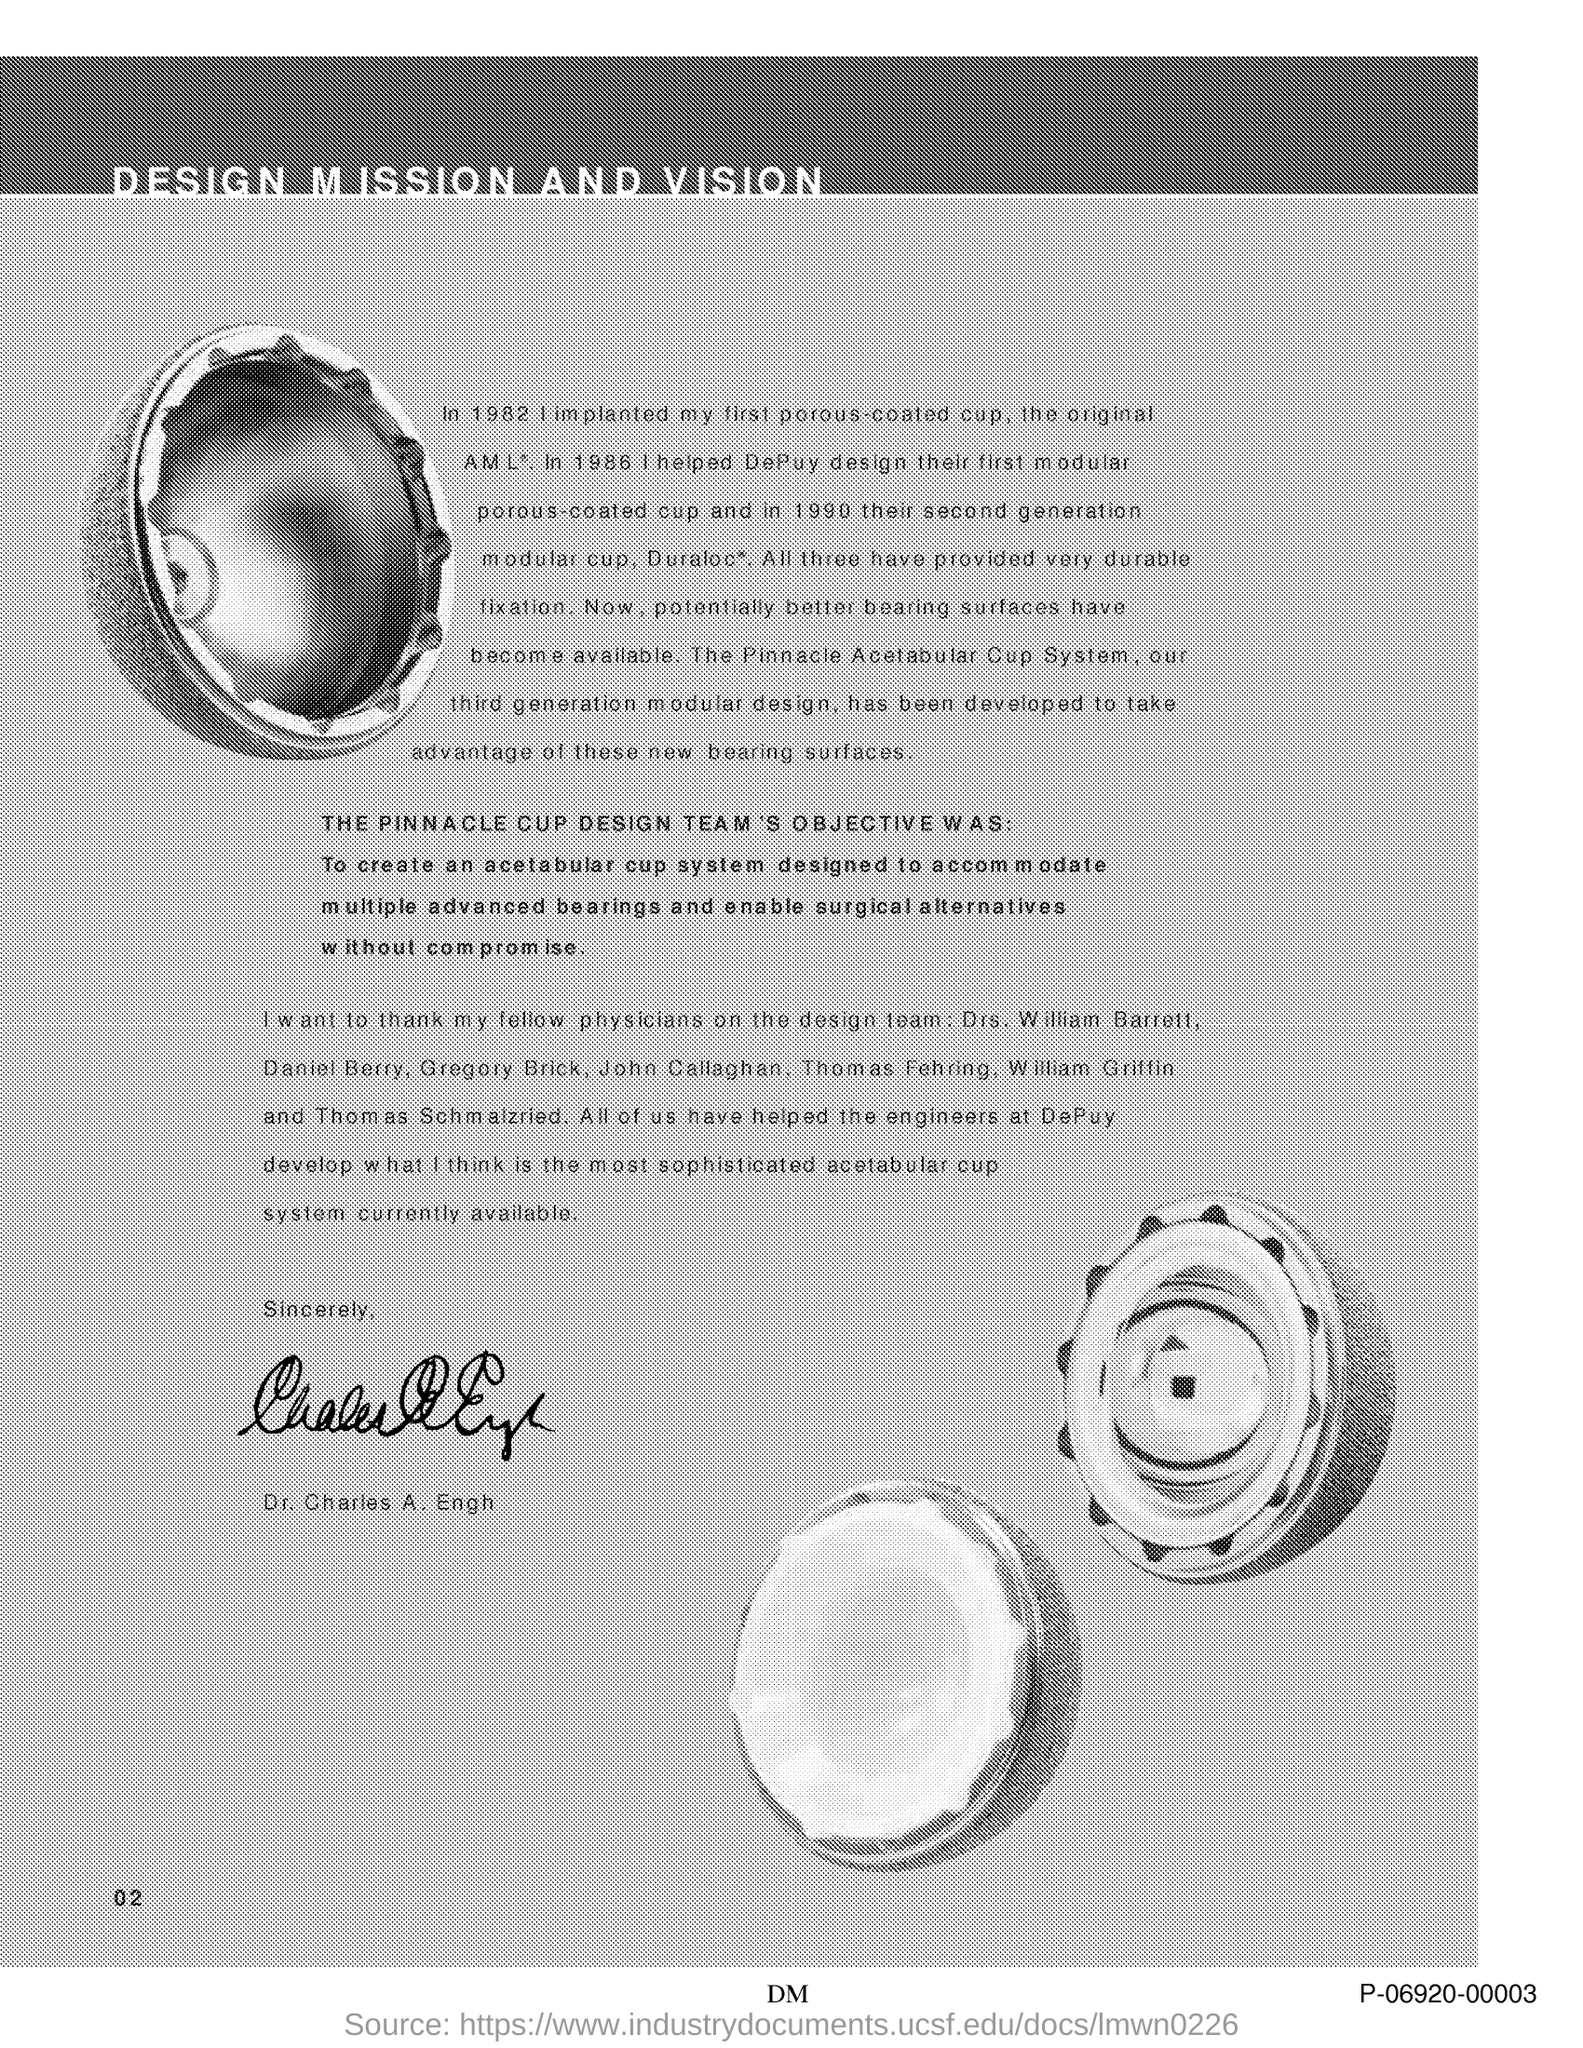Draw attention to some important aspects in this diagram. The document has been signed by Dr. Charles A. Engh. This document is titled 'Design Mission and Vision.' The page number mentioned in this document is 2. 